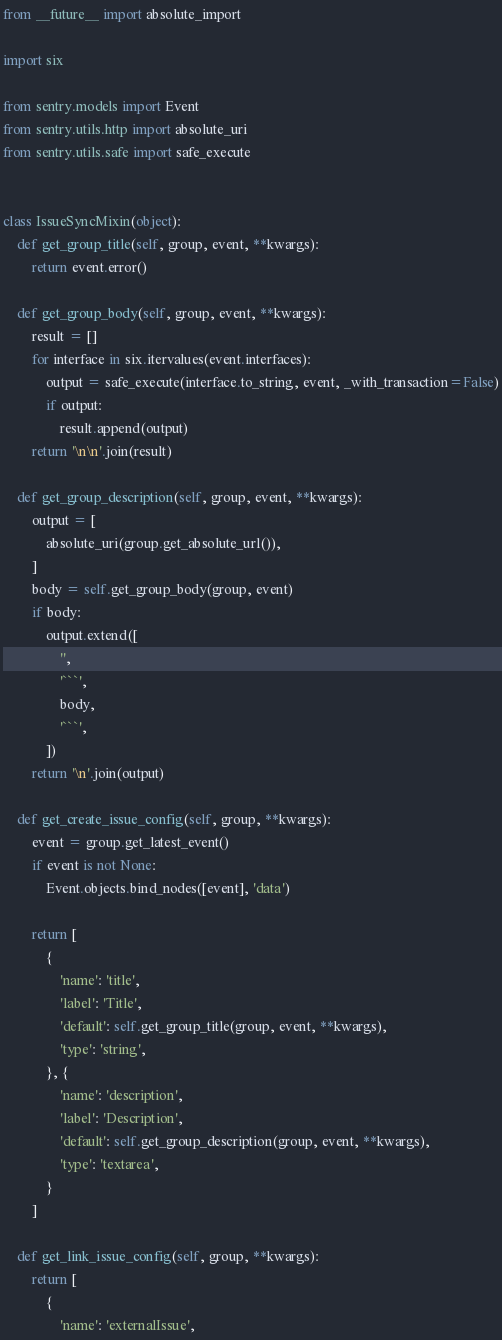<code> <loc_0><loc_0><loc_500><loc_500><_Python_>from __future__ import absolute_import

import six

from sentry.models import Event
from sentry.utils.http import absolute_uri
from sentry.utils.safe import safe_execute


class IssueSyncMixin(object):
    def get_group_title(self, group, event, **kwargs):
        return event.error()

    def get_group_body(self, group, event, **kwargs):
        result = []
        for interface in six.itervalues(event.interfaces):
            output = safe_execute(interface.to_string, event, _with_transaction=False)
            if output:
                result.append(output)
        return '\n\n'.join(result)

    def get_group_description(self, group, event, **kwargs):
        output = [
            absolute_uri(group.get_absolute_url()),
        ]
        body = self.get_group_body(group, event)
        if body:
            output.extend([
                '',
                '```',
                body,
                '```',
            ])
        return '\n'.join(output)

    def get_create_issue_config(self, group, **kwargs):
        event = group.get_latest_event()
        if event is not None:
            Event.objects.bind_nodes([event], 'data')

        return [
            {
                'name': 'title',
                'label': 'Title',
                'default': self.get_group_title(group, event, **kwargs),
                'type': 'string',
            }, {
                'name': 'description',
                'label': 'Description',
                'default': self.get_group_description(group, event, **kwargs),
                'type': 'textarea',
            }
        ]

    def get_link_issue_config(self, group, **kwargs):
        return [
            {
                'name': 'externalIssue',</code> 